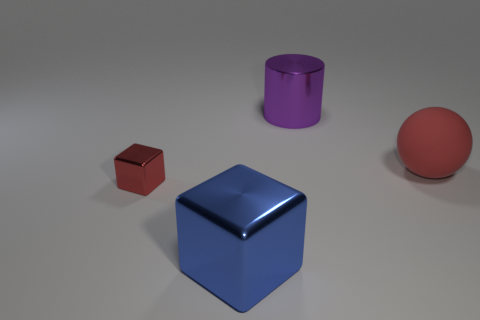Describe the overall color palette used in the image. The image features a subdued color palette with objects rendered in primary colors of red and blue, and secondary color purple amid a neutral gray background. This choice highlights the objects, giving the scene a clean, minimalistic aesthetic. 